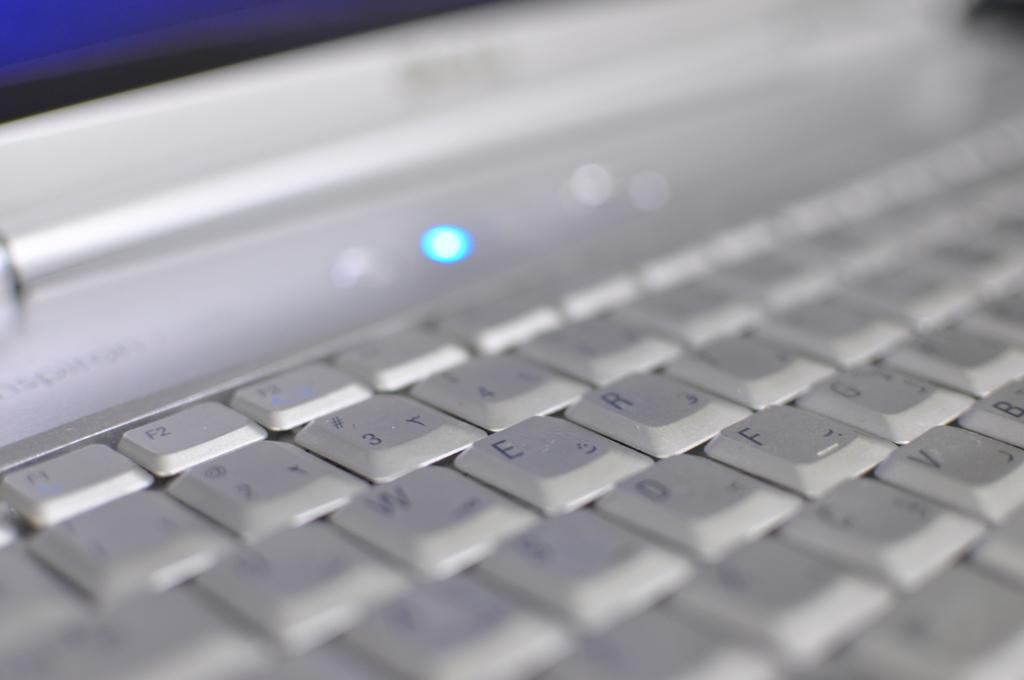<image>
Present a compact description of the photo's key features. a keyboard that has the number 3 on it 